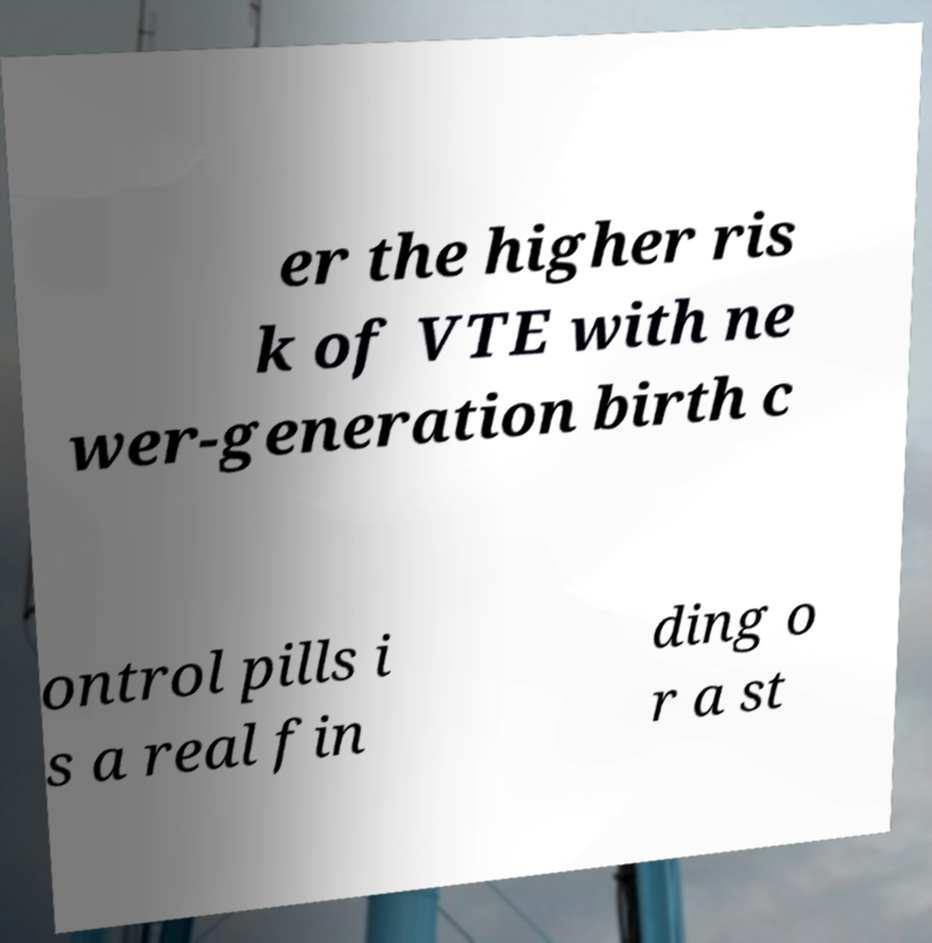What messages or text are displayed in this image? I need them in a readable, typed format. er the higher ris k of VTE with ne wer-generation birth c ontrol pills i s a real fin ding o r a st 